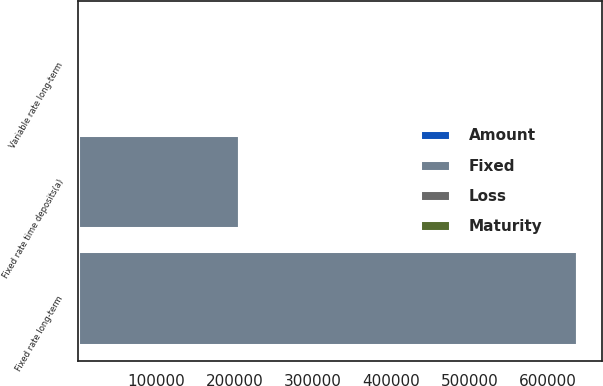<chart> <loc_0><loc_0><loc_500><loc_500><stacked_bar_chart><ecel><fcel>Fixed rate time deposits(a)<fcel>Fixed rate long-term<fcel>Variable rate long-term<nl><fcel>Fixed<fcel>205000<fcel>637241<fcel>5.1<nl><fcel>Maturity<fcel>4<fcel>7.6<fcel>1.3<nl><fcel>Amount<fcel>4.8<fcel>6.14<fcel>4.8<nl><fcel>Loss<fcel>4.96<fcel>6.48<fcel>5.1<nl></chart> 